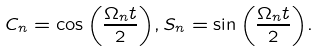<formula> <loc_0><loc_0><loc_500><loc_500>C _ { n } = \cos { \left ( \frac { \Omega _ { n } t } { 2 } \right ) } , S _ { n } = \sin { \left ( \frac { \Omega _ { n } t } { 2 } \right ) } .</formula> 